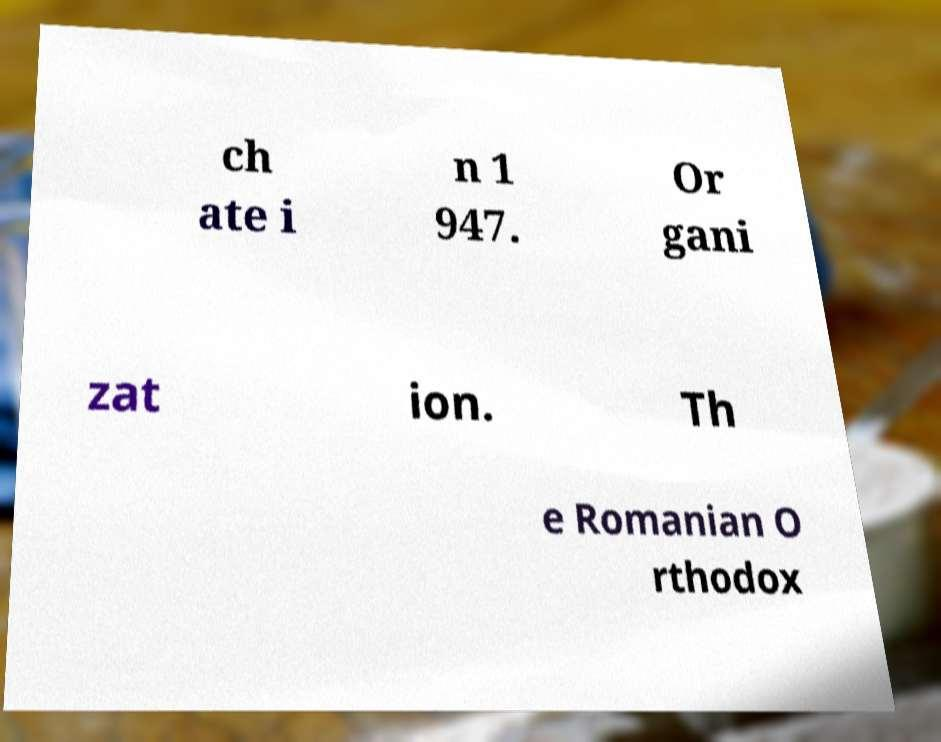Can you read and provide the text displayed in the image?This photo seems to have some interesting text. Can you extract and type it out for me? ch ate i n 1 947. Or gani zat ion. Th e Romanian O rthodox 